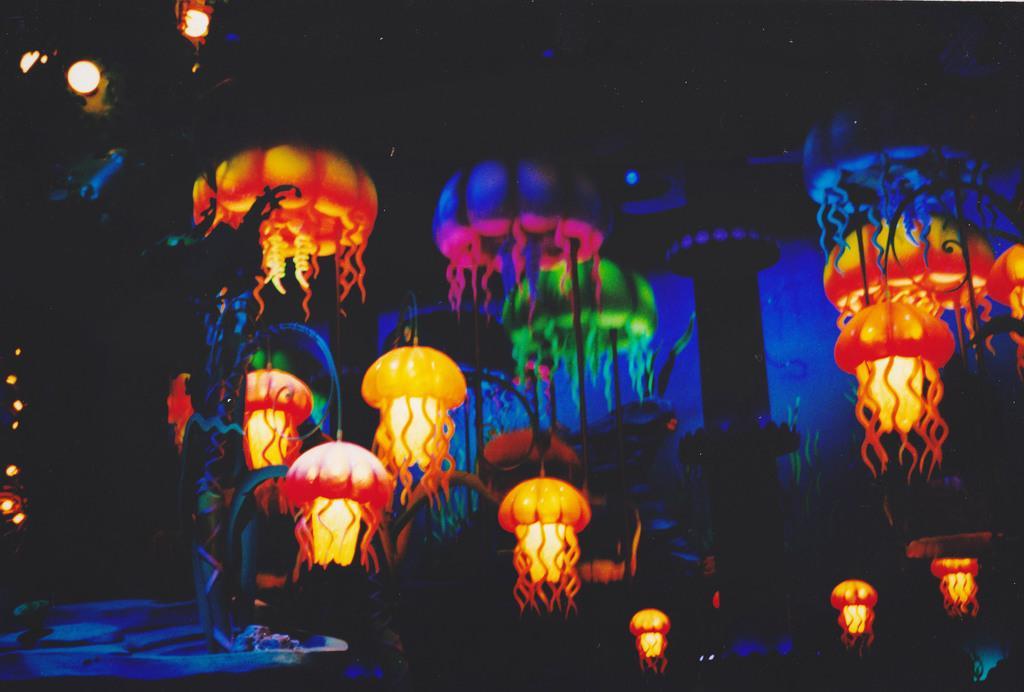How would you summarize this image in a sentence or two? In this image we can see sky lanterns. 